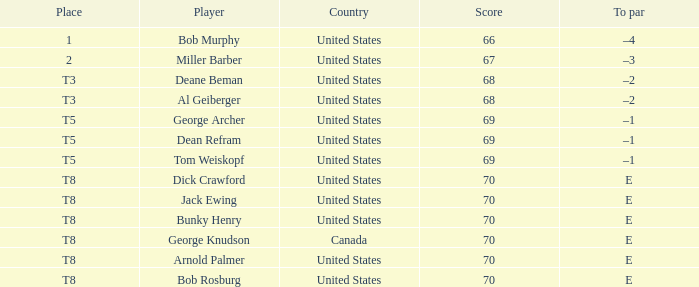Which country is George Archer from? United States. 